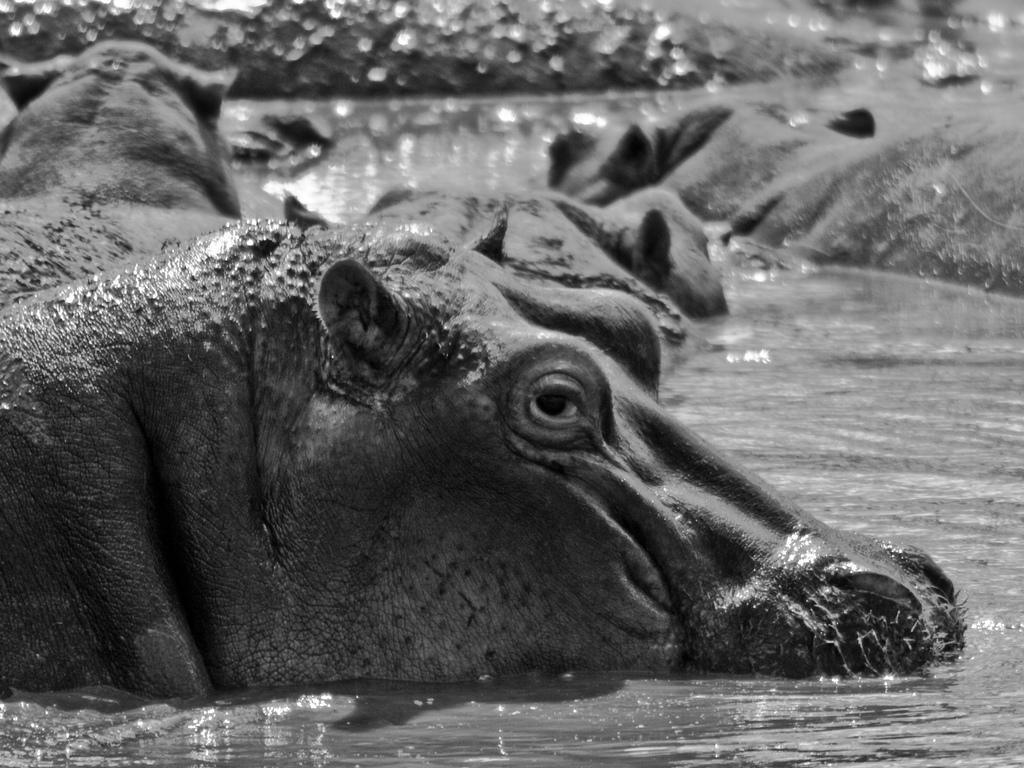What is the color scheme of the image? The image is black and white. What can be seen in the water in the image? There are animals in the water in the image. What language do the animals in the water speak in the image? The image does not depict the animals speaking any language, as animals do not communicate through human languages. 